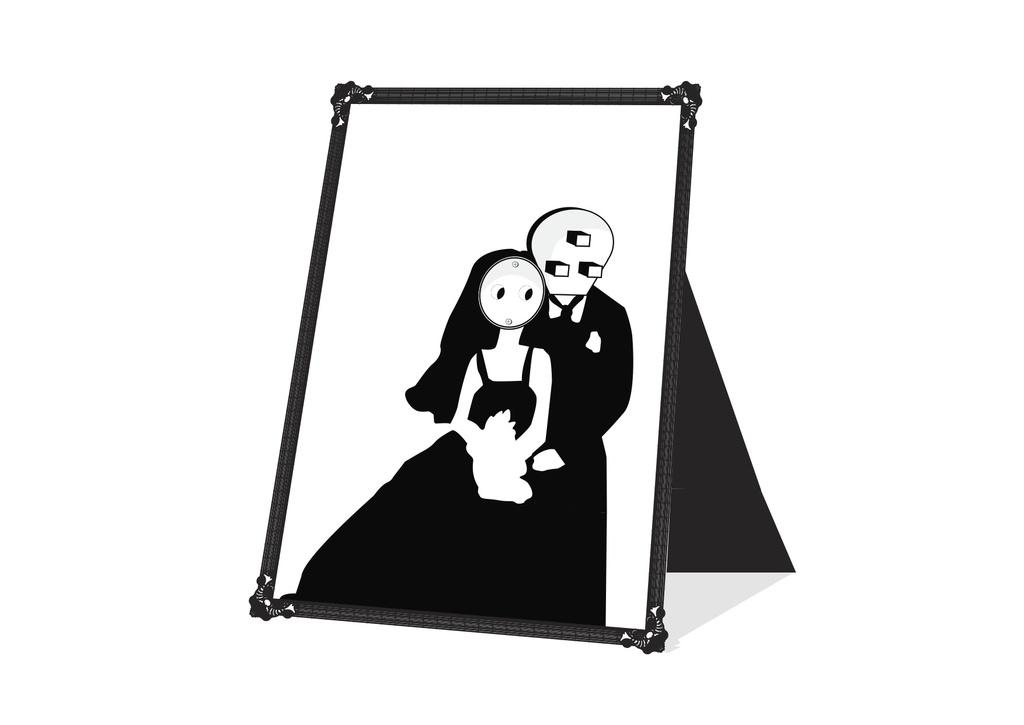What is the main object in the image? There is a board in the image. What type of images are on the board? The board contains cartoon pictures of a man and a woman. What type of vein is visible in the image? There is no vein visible in the image; it features a board with cartoon pictures of a man and a woman. What is the role of the governor in the image? There is no governor present in the image; it features a board with cartoon pictures of a man and a woman. 